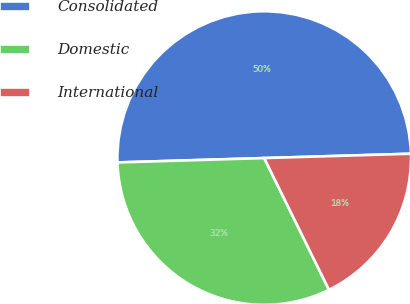<chart> <loc_0><loc_0><loc_500><loc_500><pie_chart><fcel>Consolidated<fcel>Domestic<fcel>International<nl><fcel>50.0%<fcel>31.8%<fcel>18.2%<nl></chart> 